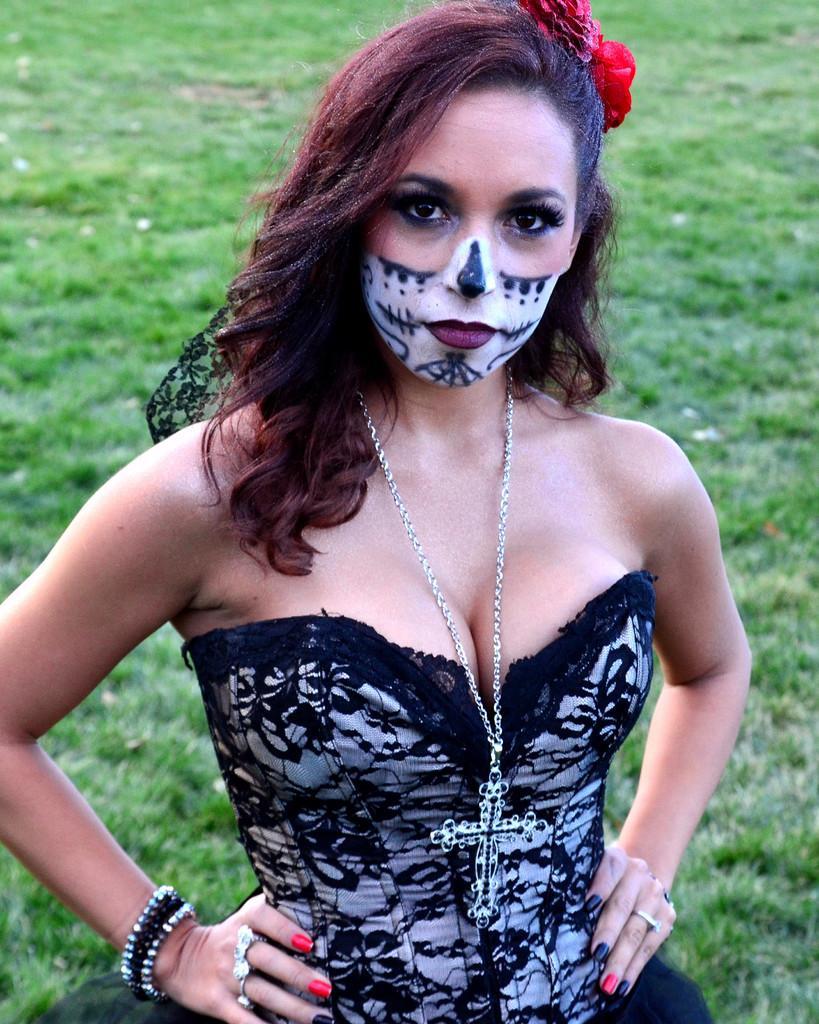In one or two sentences, can you explain what this image depicts? In this image we can see a woman with a painting on her standing on the ground. 